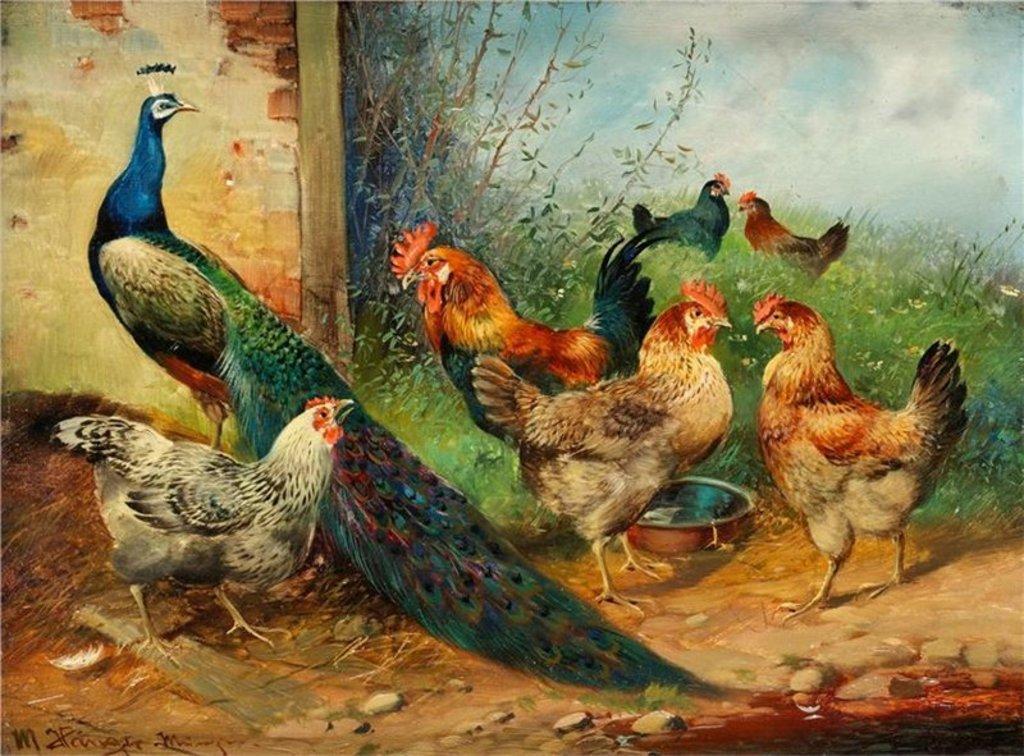What type of animals are depicted in the painting? The painting contains hens and a peacock. What is the background of the painting? There is a wall and plants in the painting. What object can be seen on the ground in the painting? There is a bowl in the painting. What part of the natural environment is visible in the painting? The sky is visible in the painting. Is there any text present in the painting? Yes, there is text written on the painting. What type of surprise can be seen in the painting? There is no surprise depicted in the painting; it features hens, a peacock, a wall, plants, a bowl, the sky, and text. 